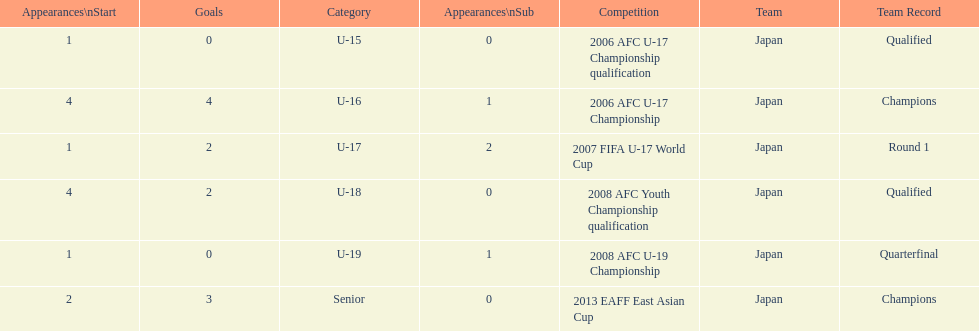What competition did japan compete in 2013? 2013 EAFF East Asian Cup. 